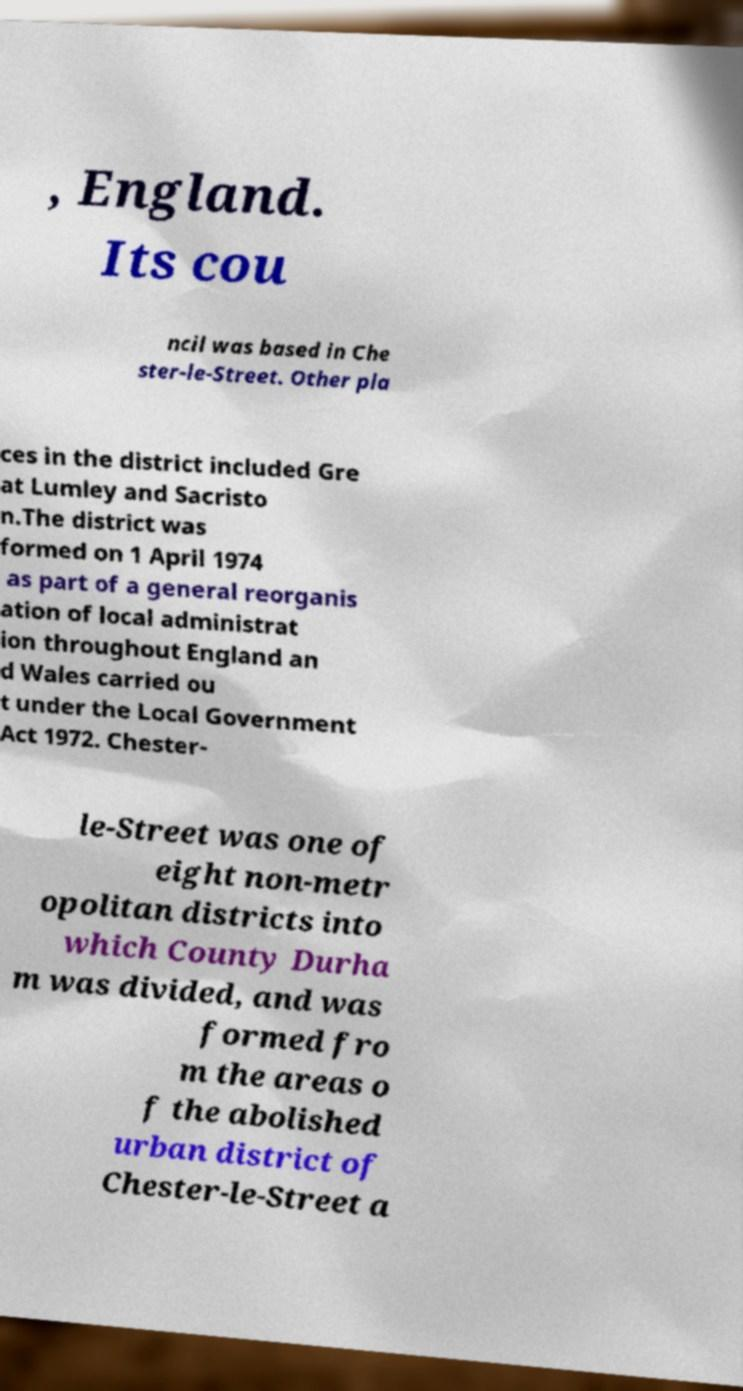For documentation purposes, I need the text within this image transcribed. Could you provide that? , England. Its cou ncil was based in Che ster-le-Street. Other pla ces in the district included Gre at Lumley and Sacristo n.The district was formed on 1 April 1974 as part of a general reorganis ation of local administrat ion throughout England an d Wales carried ou t under the Local Government Act 1972. Chester- le-Street was one of eight non-metr opolitan districts into which County Durha m was divided, and was formed fro m the areas o f the abolished urban district of Chester-le-Street a 